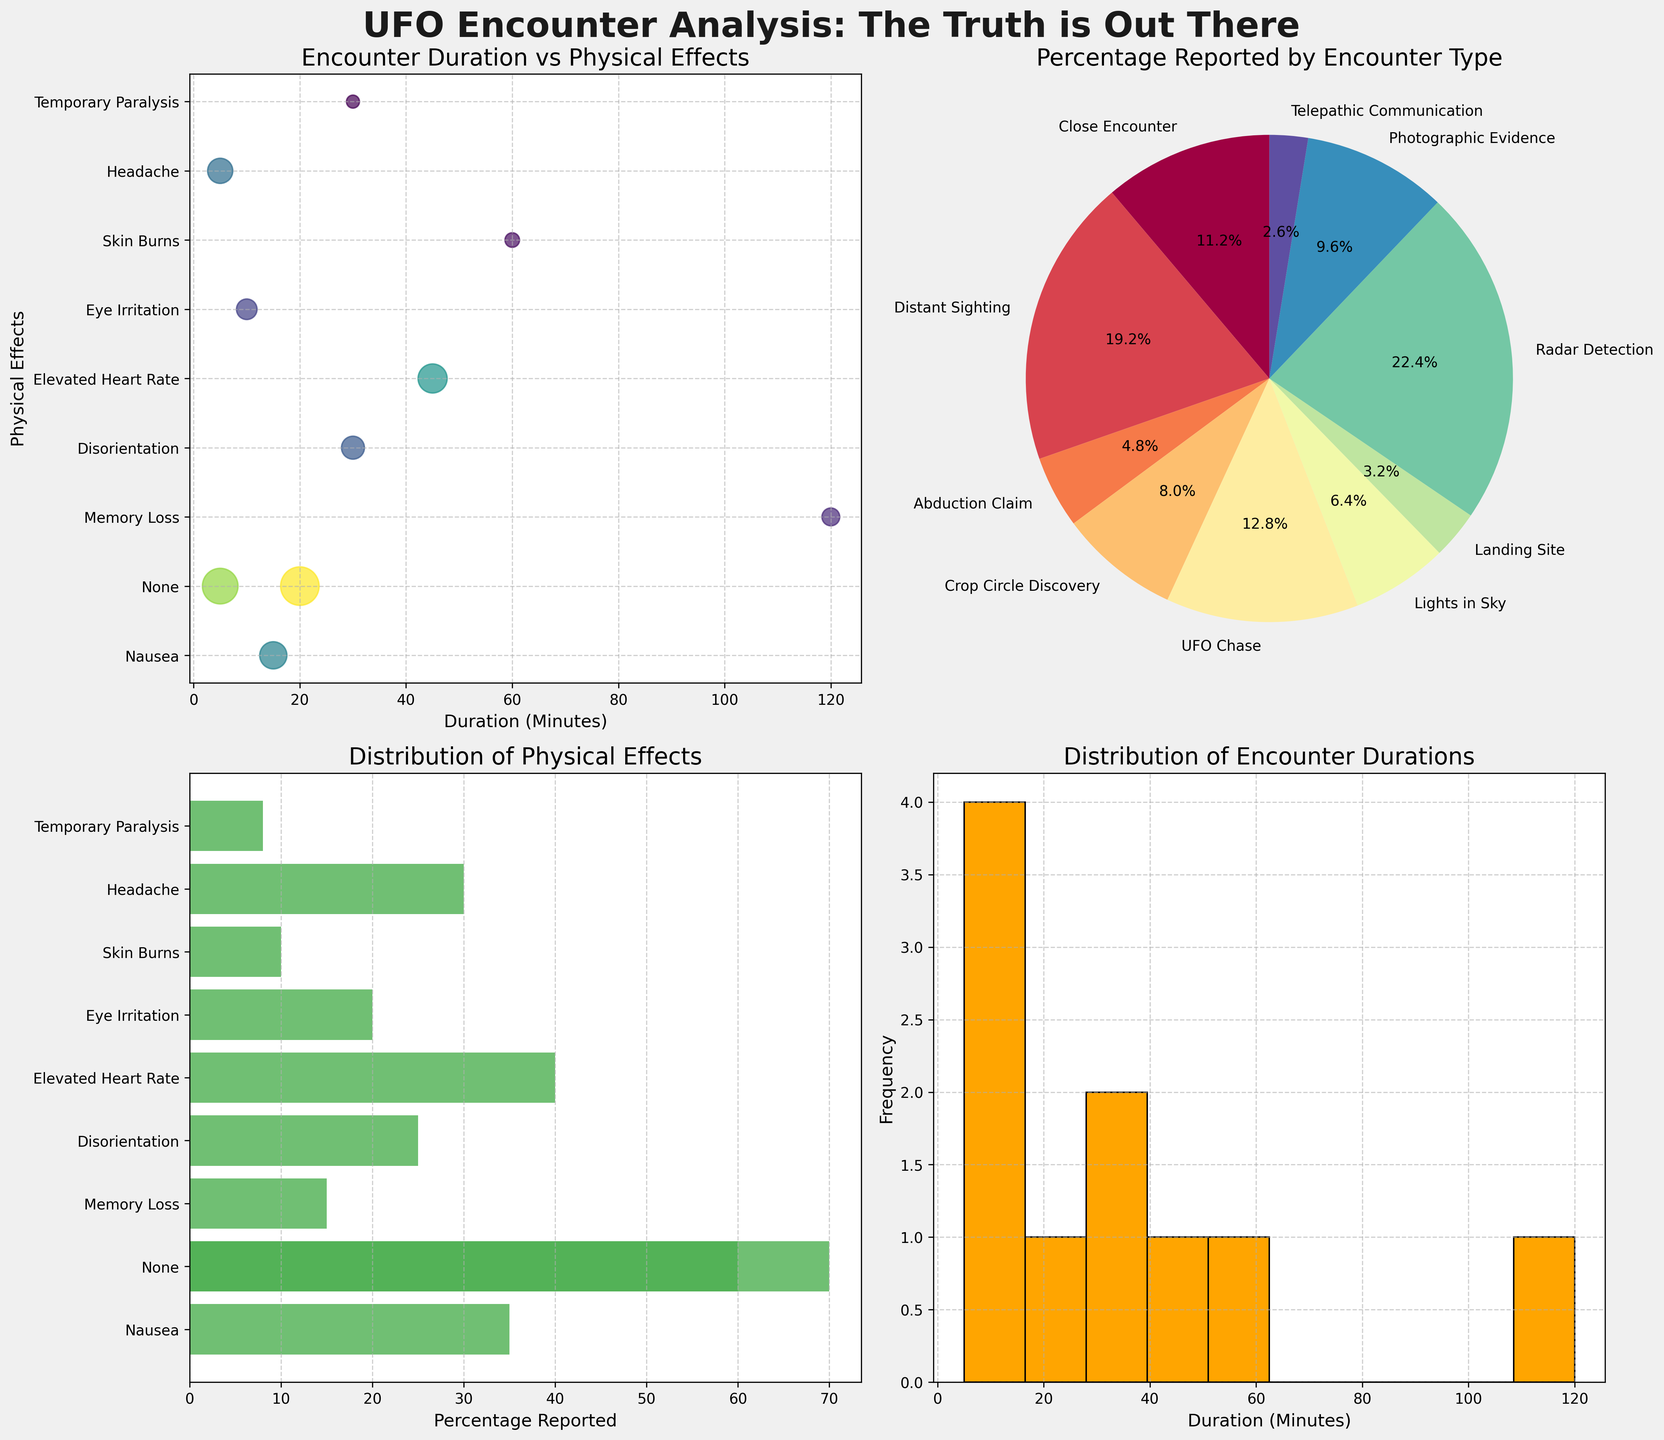what's the title of the overall figure? The text at the top center of the figure describes its main subject. It states, "UFO Encounter Analysis: The Truth is Out There".
Answer: UFO Encounter Analysis: The Truth is Out There what data is represented in the scatter plot (top left)? The scatter plot in the top left shows the relationship between the duration of the encounter in minutes and the physical effects reported. Different colors and sizes of the points indicate the percentage of reports for each combination.
Answer: Duration of encounter and physical effects which encounter type has the highest percentage reported in the pie chart? The pie chart (top right) shows various encounter types, each with a percentage value. The slice with the largest size and highest percentage value is labeled "Radar Detection".
Answer: Radar Detection how many data points are there with reported skin burns? In the bar chart (bottom left), "Skin Burns" is present among the listed physical effects. Its corresponding bar height shows the percentage, but the count of data points is uniquely represented here as one for each physical effect.
Answer: 1 what is the duration distribution range in the histogram? The histogram (bottom right) depicts encounter durations divided into bins. The x-axis showing the duration spans from 0 to around 120 minutes. Therefore, the range of the duration is 0 to 120 minutes.
Answer: 0 to 120 minutes how does the reported percentage of headache compare to nausea? By looking at the bar chart (bottom left), you can see the bar heights for "Headache" and "Nausea". "Nausea" has a value of 35% and "Headache" has a value of 30%. Comparing these, the reported percentage for "Nausea" is higher.
Answer: Nausea > Headache which encounter type associated with the shortest duration had physical effects? Referring to the scatter plot (top left), the encounter type with the shortest duration that notes physical effects is "Photographic Evidence" at 5 minutes, associated with headache.
Answer: Photographic Evidence what is the average duration of Close Encounters, Abduction Claim, and UFO Chase? By adding the durations from the data: 15 (Close Encounter) + 120 (Abduction Claim) + 45 (UFO Chase) and dividing by 3, we get the average. (15 + 120 + 45) / 3 = 180 / 3 = 60 minutes
Answer: 60 minutes which physical effect has the smallest percentage reported? The bar chart (bottom left) shows that "Temporary Paralysis" has the smallest bar, corresponding to 8%.
Answer: Temporary Paralysis do short-duration encounters (<= 20 minutes) result in more severe physical effects? Reviewing the scatter plot (top left) for encounters with durations of 20 minutes or less, we see effects like "None", "Eye Irritation", "Nausea" and "Headache". These are generally less severe compared to effects from longer encounters like "Memory Loss" and "Skin Burns".
Answer: No 